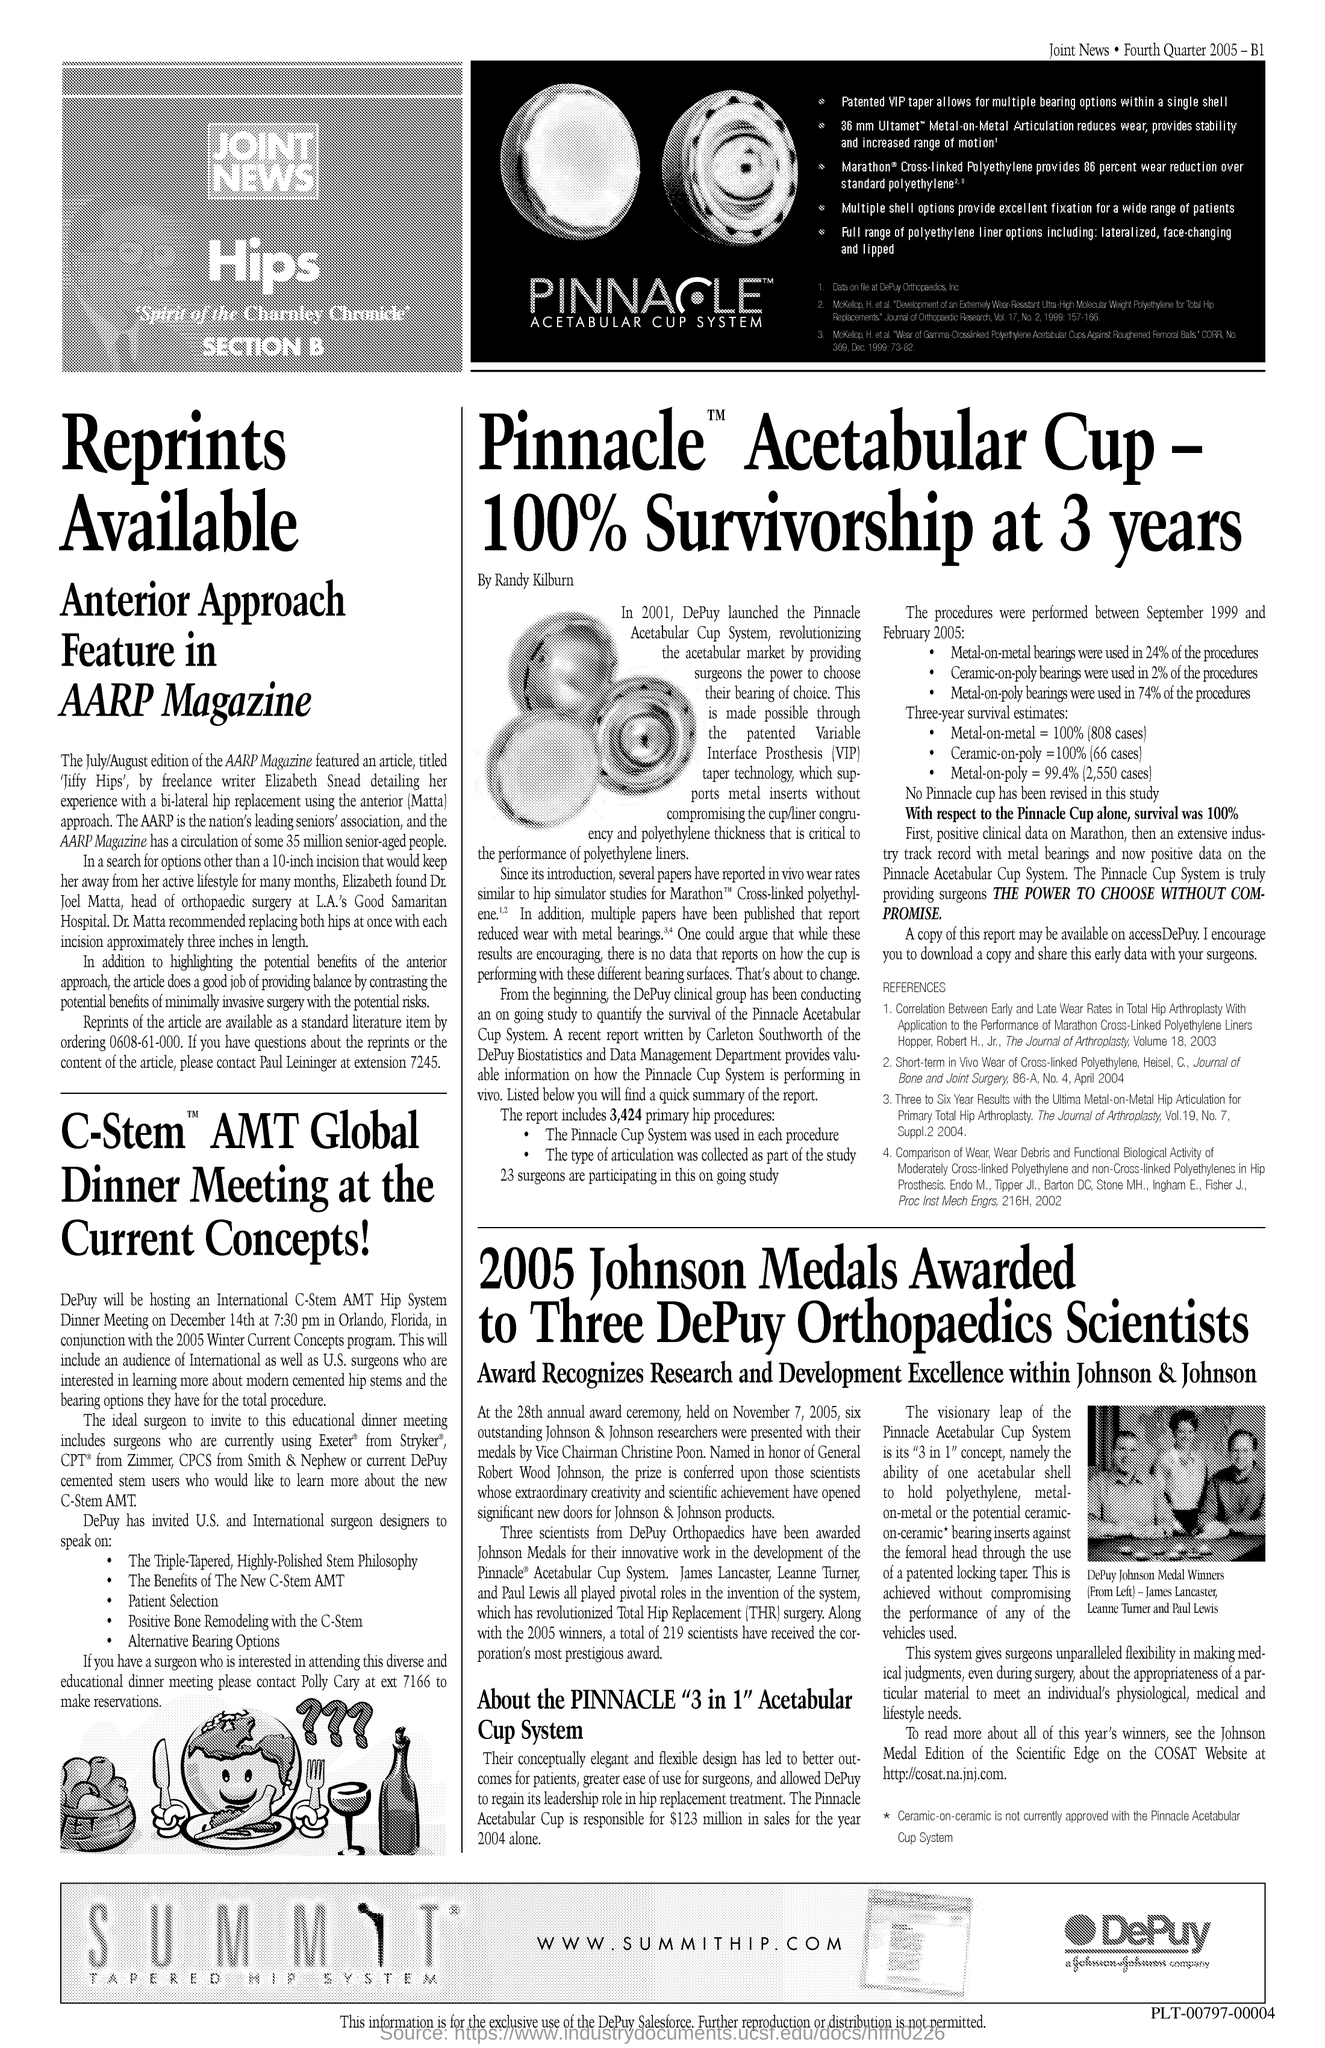Give some essential details in this illustration. The document provides a URL, which is [www.summithip.com](http://www.summithip.com). 